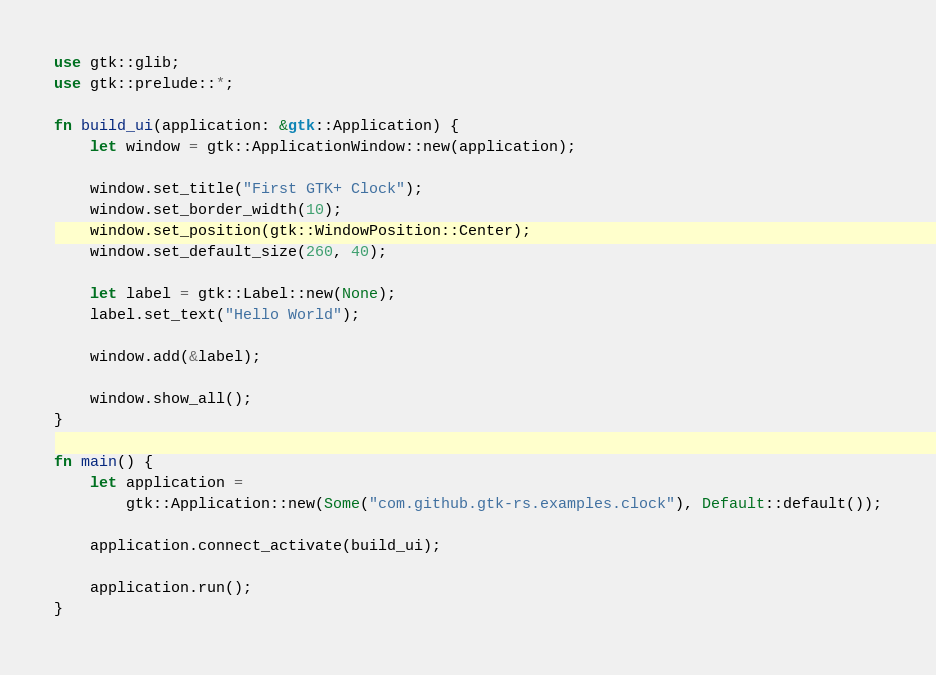<code> <loc_0><loc_0><loc_500><loc_500><_Rust_>use gtk::glib;
use gtk::prelude::*;

fn build_ui(application: &gtk::Application) {
    let window = gtk::ApplicationWindow::new(application);

    window.set_title("First GTK+ Clock");
    window.set_border_width(10);
    window.set_position(gtk::WindowPosition::Center);
    window.set_default_size(260, 40);

    let label = gtk::Label::new(None);
    label.set_text("Hello World");

    window.add(&label);

    window.show_all();
}

fn main() {
    let application =
        gtk::Application::new(Some("com.github.gtk-rs.examples.clock"), Default::default());

    application.connect_activate(build_ui);

    application.run();
}
</code> 